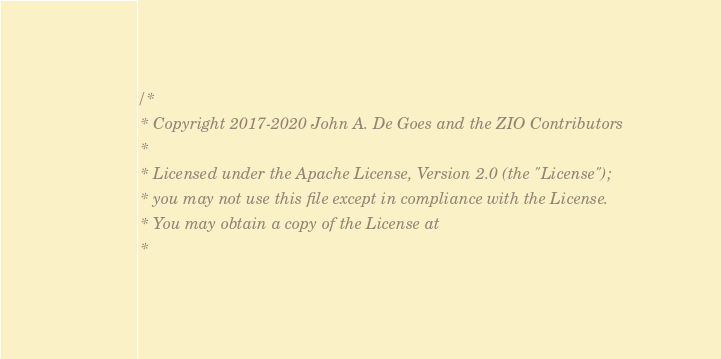<code> <loc_0><loc_0><loc_500><loc_500><_Scala_>/*
 * Copyright 2017-2020 John A. De Goes and the ZIO Contributors
 *
 * Licensed under the Apache License, Version 2.0 (the "License");
 * you may not use this file except in compliance with the License.
 * You may obtain a copy of the License at
 *</code> 